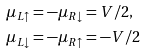<formula> <loc_0><loc_0><loc_500><loc_500>\mu _ { L \uparrow } & = - \mu _ { R \downarrow } = V / 2 , \\ \mu _ { L \downarrow } & = - \mu _ { R \uparrow } = - V / 2</formula> 